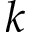Convert formula to latex. <formula><loc_0><loc_0><loc_500><loc_500>k</formula> 